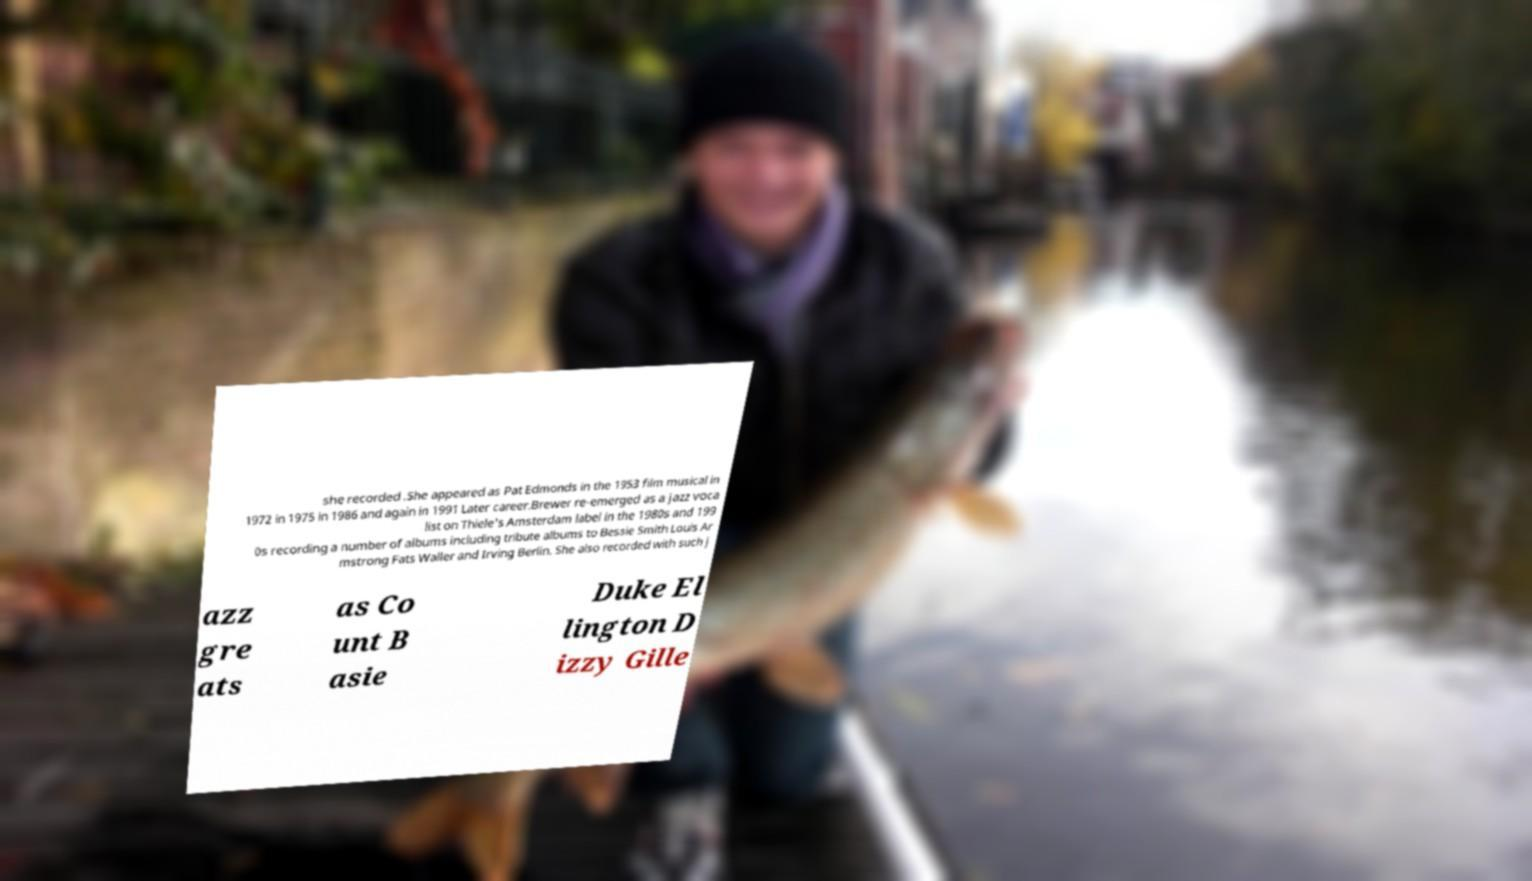There's text embedded in this image that I need extracted. Can you transcribe it verbatim? she recorded .She appeared as Pat Edmonds in the 1953 film musical in 1972 in 1975 in 1986 and again in 1991 Later career.Brewer re-emerged as a jazz voca list on Thiele's Amsterdam label in the 1980s and 199 0s recording a number of albums including tribute albums to Bessie Smith Louis Ar mstrong Fats Waller and Irving Berlin. She also recorded with such j azz gre ats as Co unt B asie Duke El lington D izzy Gille 